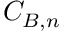Convert formula to latex. <formula><loc_0><loc_0><loc_500><loc_500>{ C } _ { B , n }</formula> 